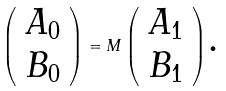<formula> <loc_0><loc_0><loc_500><loc_500>\left ( \begin{array} { c } A _ { 0 } \\ B _ { 0 } \end{array} \right ) = M \left ( \begin{array} { c } A _ { 1 } \\ B _ { 1 } \end{array} \right ) \text {.}</formula> 